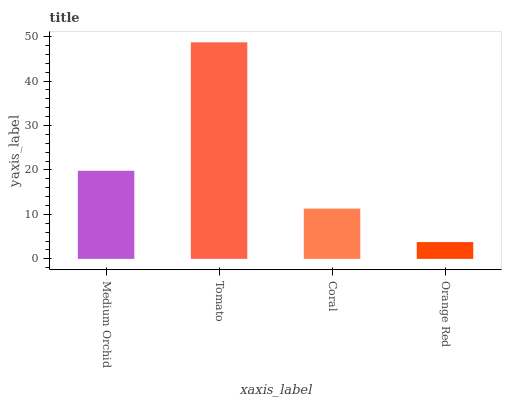Is Orange Red the minimum?
Answer yes or no. Yes. Is Tomato the maximum?
Answer yes or no. Yes. Is Coral the minimum?
Answer yes or no. No. Is Coral the maximum?
Answer yes or no. No. Is Tomato greater than Coral?
Answer yes or no. Yes. Is Coral less than Tomato?
Answer yes or no. Yes. Is Coral greater than Tomato?
Answer yes or no. No. Is Tomato less than Coral?
Answer yes or no. No. Is Medium Orchid the high median?
Answer yes or no. Yes. Is Coral the low median?
Answer yes or no. Yes. Is Orange Red the high median?
Answer yes or no. No. Is Orange Red the low median?
Answer yes or no. No. 